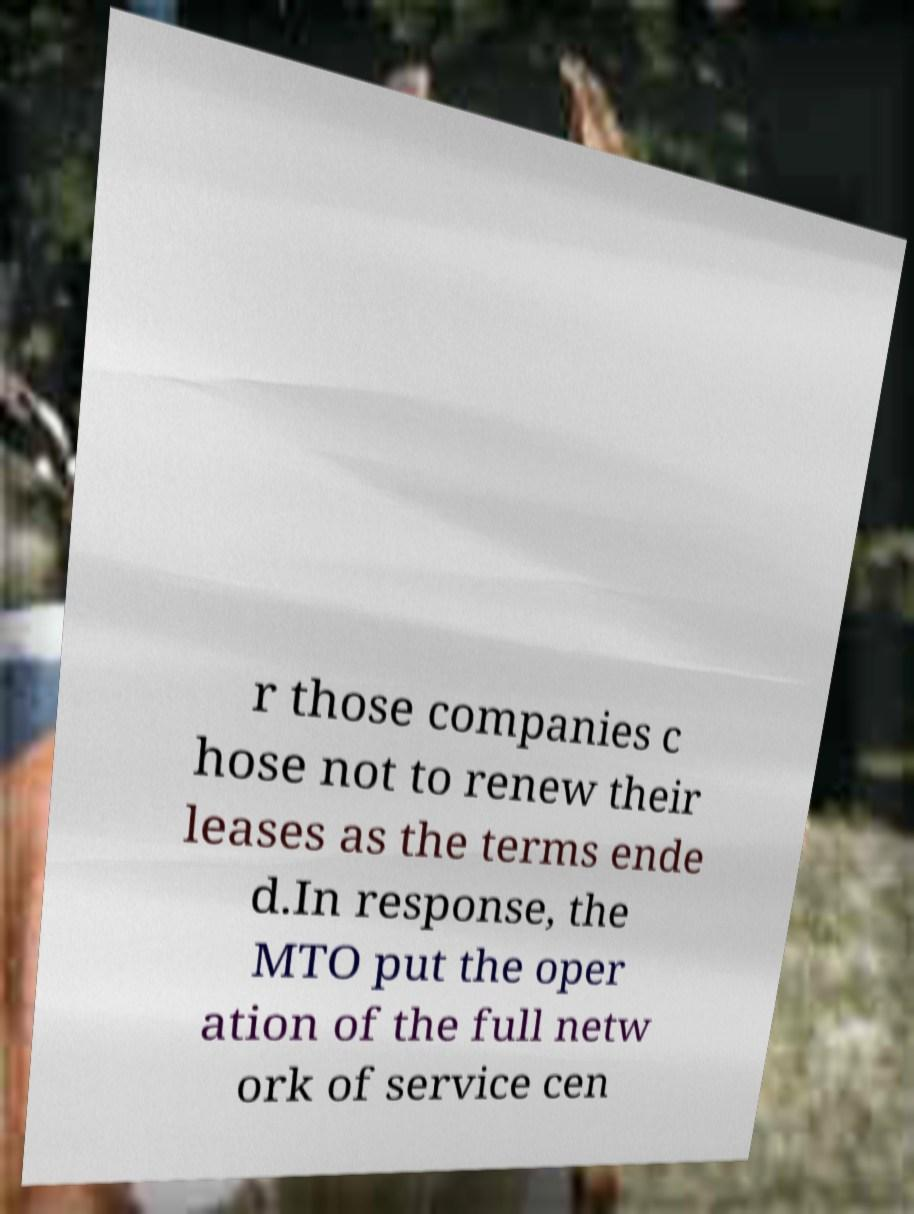For documentation purposes, I need the text within this image transcribed. Could you provide that? r those companies c hose not to renew their leases as the terms ende d.In response, the MTO put the oper ation of the full netw ork of service cen 